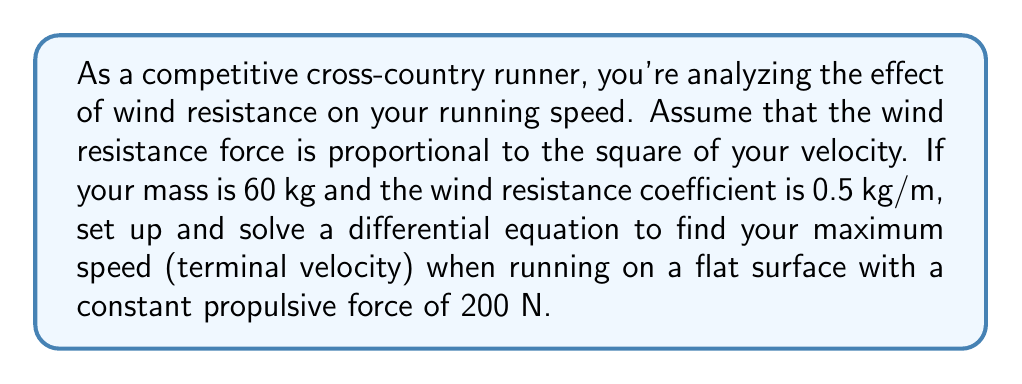Solve this math problem. Let's approach this problem step by step:

1) First, let's define our variables:
   $m$ = mass (60 kg)
   $v$ = velocity (m/s)
   $k$ = wind resistance coefficient (0.5 kg/m)
   $F$ = propulsive force (200 N)

2) The net force acting on you is the difference between the propulsive force and the wind resistance:

   $F_{net} = F - kv^2$

3) According to Newton's Second Law, $F = ma$. In this case:

   $m\frac{dv}{dt} = F - kv^2$

4) This is our differential equation. Let's rearrange it:

   $\frac{dv}{dt} = \frac{F}{m} - \frac{k}{m}v^2$

5) At terminal velocity, acceleration is zero, so $\frac{dv}{dt} = 0$. Let's call this maximum velocity $v_{max}$:

   $0 = \frac{F}{m} - \frac{k}{m}v_{max}^2$

6) Solving for $v_{max}$:

   $\frac{k}{m}v_{max}^2 = \frac{F}{m}$
   
   $v_{max}^2 = \frac{F}{k}$
   
   $v_{max} = \sqrt{\frac{F}{k}}$

7) Now let's substitute our values:

   $v_{max} = \sqrt{\frac{200}{0.5}} = \sqrt{400} = 20$ m/s

Therefore, your maximum speed (terminal velocity) will be 20 m/s.
Answer: The maximum speed (terminal velocity) is 20 m/s. 